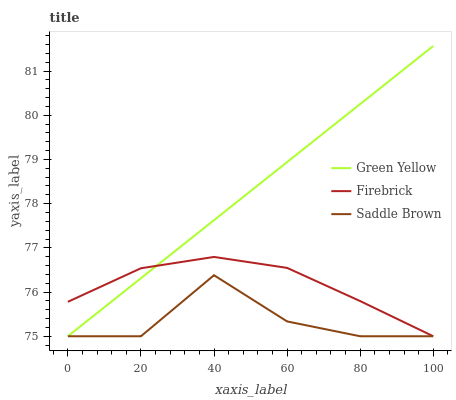Does Saddle Brown have the minimum area under the curve?
Answer yes or no. Yes. Does Green Yellow have the maximum area under the curve?
Answer yes or no. Yes. Does Green Yellow have the minimum area under the curve?
Answer yes or no. No. Does Saddle Brown have the maximum area under the curve?
Answer yes or no. No. Is Green Yellow the smoothest?
Answer yes or no. Yes. Is Saddle Brown the roughest?
Answer yes or no. Yes. Is Saddle Brown the smoothest?
Answer yes or no. No. Is Green Yellow the roughest?
Answer yes or no. No. Does Firebrick have the lowest value?
Answer yes or no. Yes. Does Green Yellow have the highest value?
Answer yes or no. Yes. Does Saddle Brown have the highest value?
Answer yes or no. No. Does Firebrick intersect Green Yellow?
Answer yes or no. Yes. Is Firebrick less than Green Yellow?
Answer yes or no. No. Is Firebrick greater than Green Yellow?
Answer yes or no. No. 